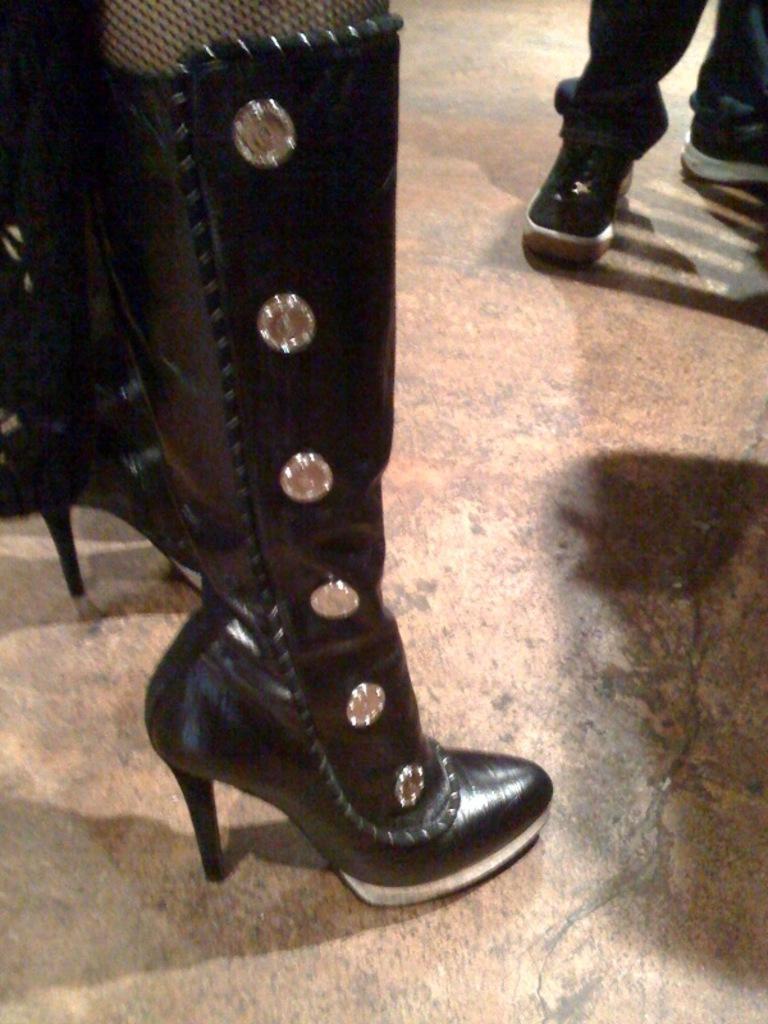Describe this image in one or two sentences. In this image I can see a shoe which is in black color, background I can a person standing and the person is wearing black pant and black color shoes. 